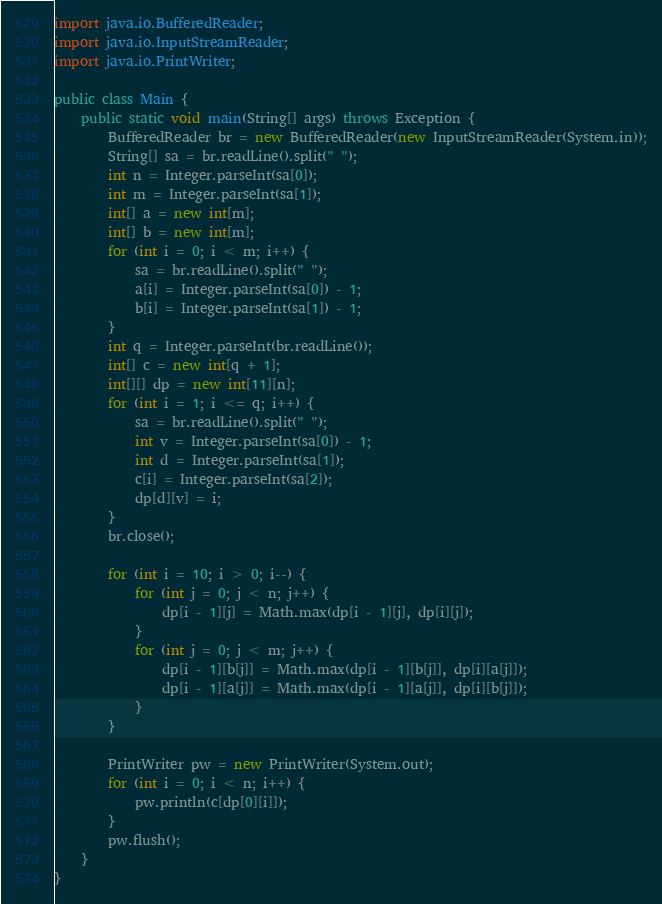Convert code to text. <code><loc_0><loc_0><loc_500><loc_500><_Java_>import java.io.BufferedReader;
import java.io.InputStreamReader;
import java.io.PrintWriter;

public class Main {
	public static void main(String[] args) throws Exception {
		BufferedReader br = new BufferedReader(new InputStreamReader(System.in));
		String[] sa = br.readLine().split(" ");
		int n = Integer.parseInt(sa[0]);
		int m = Integer.parseInt(sa[1]);
		int[] a = new int[m];
		int[] b = new int[m];
		for (int i = 0; i < m; i++) {
			sa = br.readLine().split(" ");
			a[i] = Integer.parseInt(sa[0]) - 1;
			b[i] = Integer.parseInt(sa[1]) - 1;
		}
		int q = Integer.parseInt(br.readLine());
		int[] c = new int[q + 1];
		int[][] dp = new int[11][n];
		for (int i = 1; i <= q; i++) {
			sa = br.readLine().split(" ");
			int v = Integer.parseInt(sa[0]) - 1;
			int d = Integer.parseInt(sa[1]);
			c[i] = Integer.parseInt(sa[2]);
			dp[d][v] = i;
		}
		br.close();

		for (int i = 10; i > 0; i--) {
			for (int j = 0; j < n; j++) {
				dp[i - 1][j] = Math.max(dp[i - 1][j], dp[i][j]);
			}
			for (int j = 0; j < m; j++) {
				dp[i - 1][b[j]] = Math.max(dp[i - 1][b[j]], dp[i][a[j]]);
				dp[i - 1][a[j]] = Math.max(dp[i - 1][a[j]], dp[i][b[j]]);
			}
		}

		PrintWriter pw = new PrintWriter(System.out);
		for (int i = 0; i < n; i++) {
			pw.println(c[dp[0][i]]);
		}
		pw.flush();
	}
}
</code> 